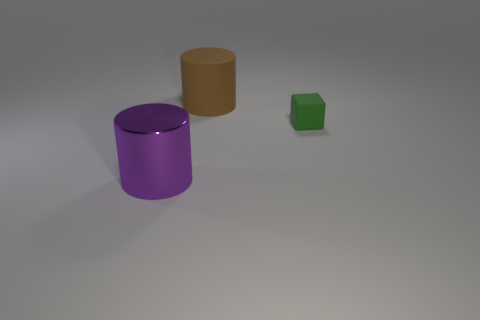What color is the object that is both to the right of the large purple metallic object and in front of the brown matte cylinder?
Your answer should be compact. Green. What material is the green cube behind the purple metal cylinder?
Provide a succinct answer. Rubber. Are there any big red metallic objects that have the same shape as the big brown matte thing?
Ensure brevity in your answer.  No. What number of other things are there of the same shape as the tiny thing?
Your response must be concise. 0. There is a large brown rubber object; is its shape the same as the object in front of the small green matte cube?
Offer a very short reply. Yes. Is there any other thing that is the same material as the small object?
Provide a succinct answer. Yes. There is a brown object that is the same shape as the large purple metal thing; what is its material?
Your answer should be very brief. Rubber. What number of tiny objects are gray matte cylinders or brown rubber cylinders?
Your response must be concise. 0. Are there fewer small matte cubes that are in front of the matte block than big things that are in front of the big purple metal thing?
Give a very brief answer. No. How many things are either green objects or large cyan matte cylinders?
Offer a very short reply. 1. 